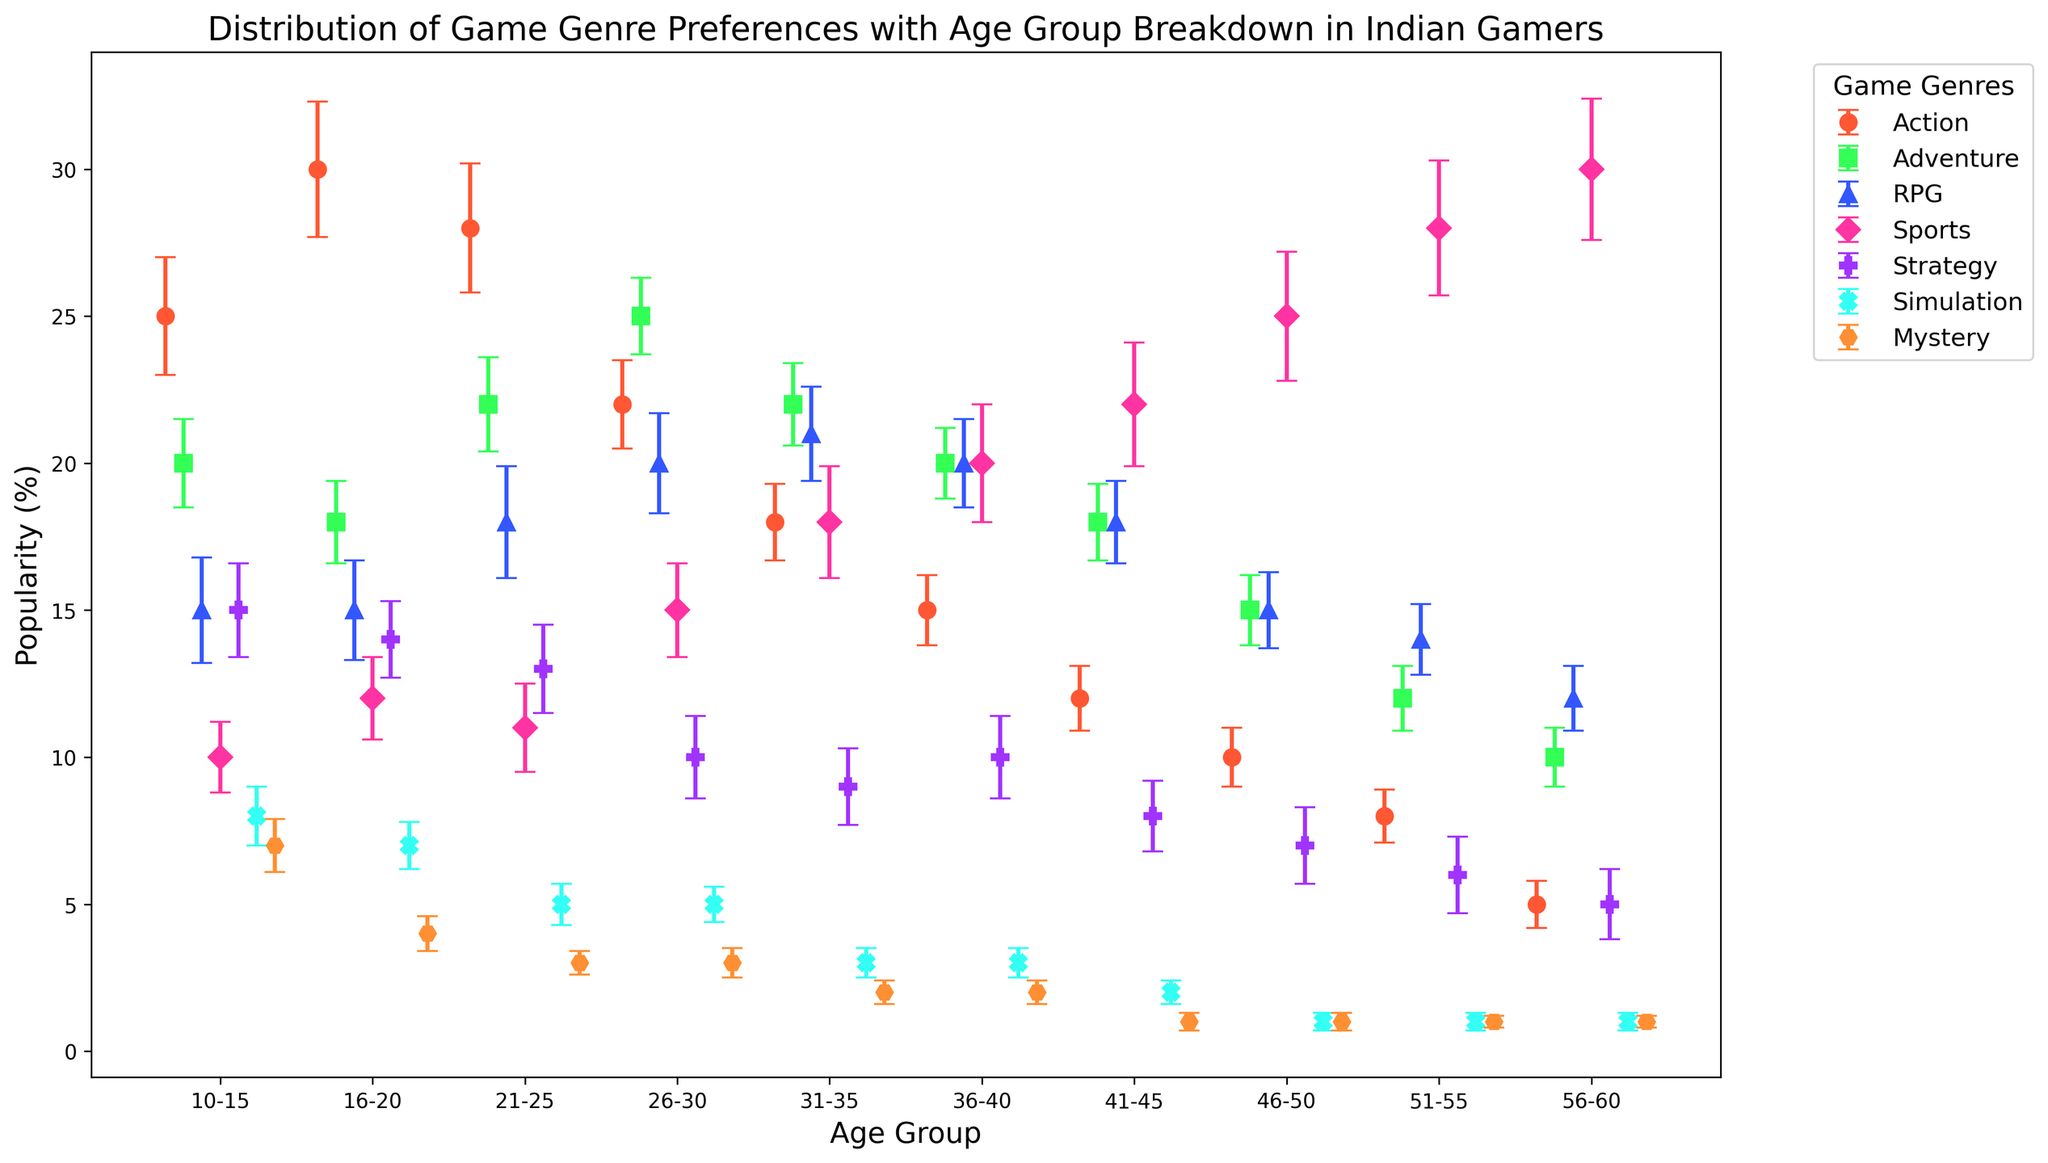What age group shows the highest preference for Sports games? The chart shows the popularity percentage of different game genres categorized by age groups. By visually inspecting the plot for Sports games, the highest point on the y-axis corresponds to the 56-60 age group.
Answer: 56-60 Which game genre has the lowest preference among the 10-15 age group? Observing the error bars for the 10-15 age group, Mystery games have the lowest popularity percentage.
Answer: Mystery Between the age groups of 21-25 and 31-35, which age group prefers RPG games more? Comparing the data points for RPG games, the 31-35 age group has a slightly higher popularity percentage than the 21-25 group.
Answer: 31-35 What is the trend in the popularity of Action games as the age group increases? By looking at the data points for Action games across different age groups, we can see that the popularity decreases steadily as the age group increases.
Answer: Decreasing For the age group 41-45, which game genres have a popularity percentage within the error range of ±1 from the RPG genre? For the 41-45 age group, the popularity of RPG games is 18%. The game genres that fall within the ±1 error range from this value are Adventure (18%), Sports (22%), and Strategy (8%), given the similar standard deviations.
Answer: Adventure and Strategy Do Simulation games show higher popularity among age groups 26-30 or 56-60? Comparing the data points and their error bars for both age groups, Simulation games have similar popularity but the actual values show a tiny higher preference in the 26-30 group.
Answer: 26-30 Which two game genres show the most consistent levels of preference, as indicated by the smallest error bars, across the age groups? By examining the standard deviations for each genre, Simulation and Mystery games tend to have the smallest error bars, indicating more consistent preference levels across different age groups.
Answer: Simulation and Mystery Is there a marked difference in Adventure game popularity between the 10-15 and 26-30 age groups? Looking at the points and their error bars, Adventure game popularity is higher in the 26-30 group than the 10-15 group. However, considering the error bars, the preference difference is not statistically significant.
Answer: No marked difference What game genre is the most popular in the 16-20 age group, and by what percentage does it surpass the least popular genre in the same group? From the plot, Action games are the most popular at 30%, and Simulation the least popular at 7%. The difference in percentage between them is 30 - 7 = 23%.
Answer: Action, 23% Which genre sees a significant increase in popularity from the 10-15 age group to the 51-55 age group? Observing the trends, the Sports genre shows a significant increase in popularity from 10% in the 10-15 group to 28% in the 51-55 group.
Answer: Sports 